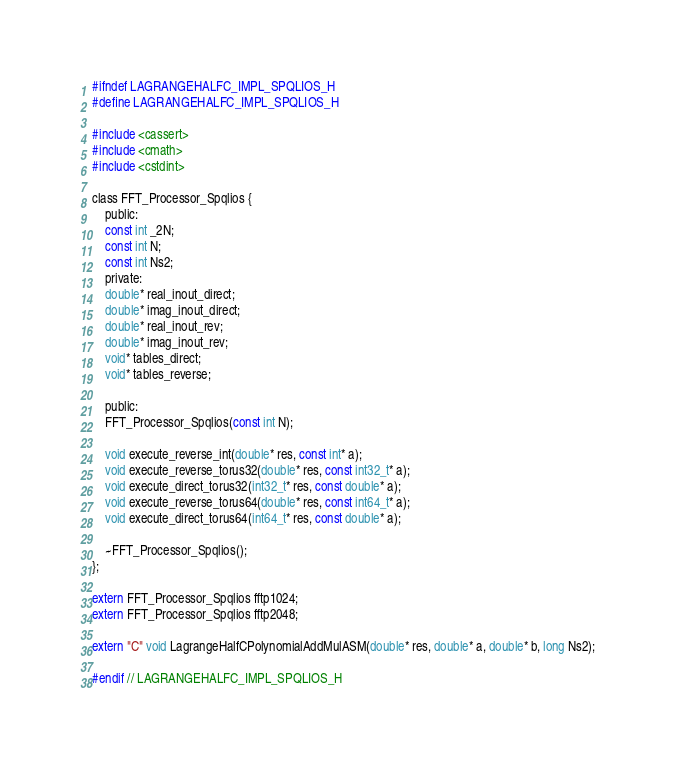Convert code to text. <code><loc_0><loc_0><loc_500><loc_500><_C_>#ifndef LAGRANGEHALFC_IMPL_SPQLIOS_H
#define LAGRANGEHALFC_IMPL_SPQLIOS_H

#include <cassert>
#include <cmath>
#include <cstdint>

class FFT_Processor_Spqlios {
    public:
    const int _2N;
    const int N;    
    const int Ns2;
    private:
    double* real_inout_direct;
    double* imag_inout_direct;
    double* real_inout_rev;
    double* imag_inout_rev;
    void* tables_direct;
    void* tables_reverse;
    
    public:
    FFT_Processor_Spqlios(const int N);

    void execute_reverse_int(double* res, const int* a);
    void execute_reverse_torus32(double* res, const int32_t* a);
    void execute_direct_torus32(int32_t* res, const double* a);
    void execute_reverse_torus64(double* res, const int64_t* a);
    void execute_direct_torus64(int64_t* res, const double* a);

    ~FFT_Processor_Spqlios();
};

extern FFT_Processor_Spqlios fftp1024;
extern FFT_Processor_Spqlios fftp2048;

extern "C" void LagrangeHalfCPolynomialAddMulASM(double* res, double* a, double* b, long Ns2);

#endif // LAGRANGEHALFC_IMPL_SPQLIOS_H
</code> 